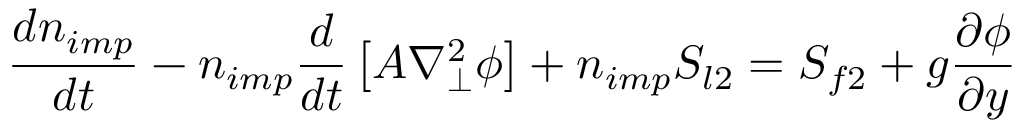<formula> <loc_0><loc_0><loc_500><loc_500>\frac { d n _ { i m p } } { d t } - n _ { i m p } \frac { d } { d t } \left [ A \nabla _ { \perp } ^ { 2 } \phi \right ] + n _ { i m p } S _ { l 2 } = S _ { f 2 } + g \frac { \partial \phi } { \partial y }</formula> 